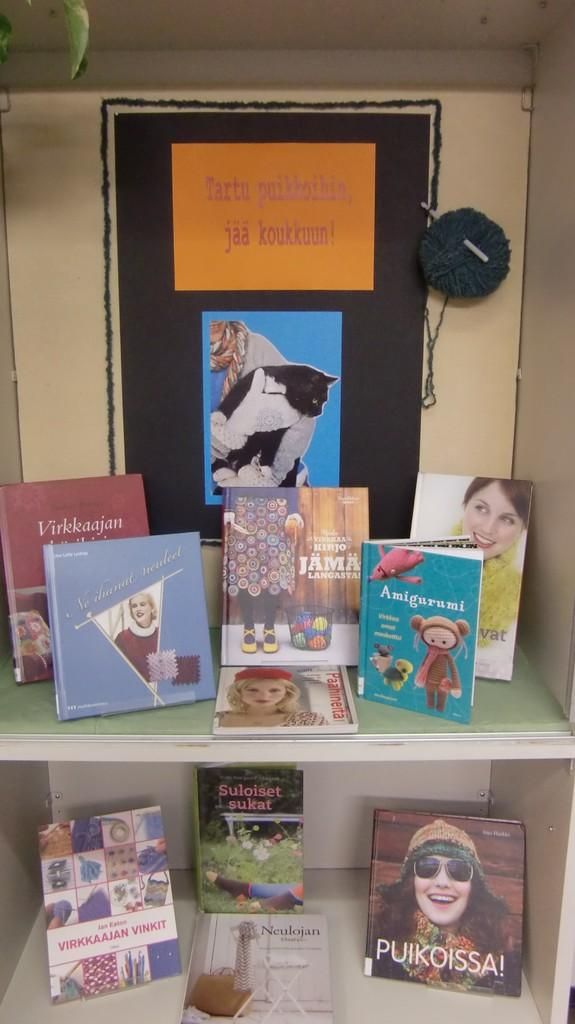What can be seen on the shelf in the image? There are many books on the shelf in the image. What is on the back wall in the image? There is a poster on the back wall in the image. What is depicted on the poster? The poster features a woolen ball and a needle. How many people are in the group depicted on the poster? There is no group of people depicted on the poster; it features a woolen ball and a needle. What type of roof is shown on the poster? There is no roof depicted on the poster; it features a woolen ball and a needle. 